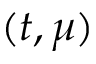Convert formula to latex. <formula><loc_0><loc_0><loc_500><loc_500>( t , \mu )</formula> 